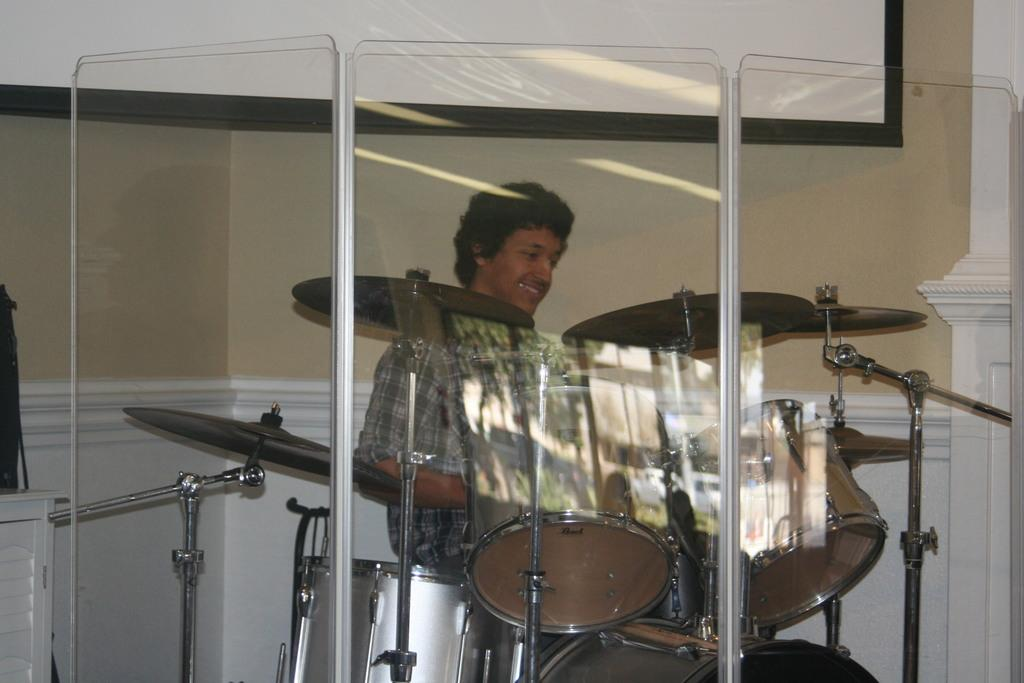What is the person in the image doing? There is a person sitting in the image. What else can be seen in the image besides the person? There are musical instruments in the image. What is visible in the background of the image? There is a wall in the background of the image. Can you describe the wall in the background? There is a poster on the wall in the background. What type of cloth is the queen wearing in the image? There is no queen present in the image, so it is not possible to answer that question. 